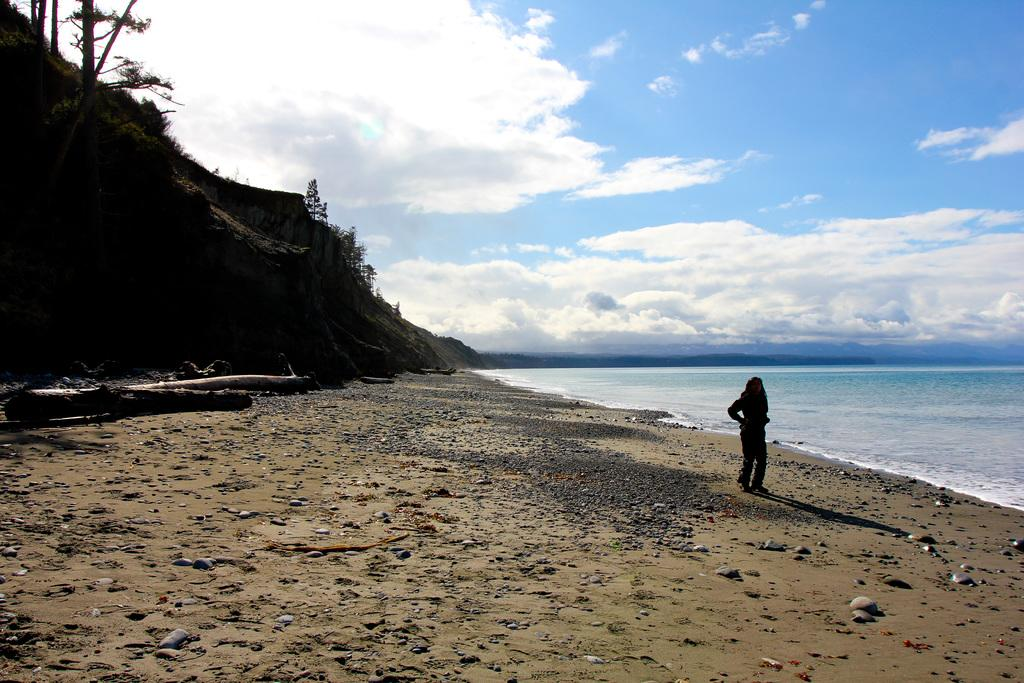What type of natural feature can be seen in the image? There is an ocean in the image. What are the women in the image doing? The women are standing in the image. What type of terrain is visible in the image? There are stones visible in the image. What type of vegetation is present in the image? There are trees in the image. What is visible in the sky in the image? The sky is visible in the image, and clouds are present. What is on the ground in the image? There are stones on the ground in the image. What is the purpose of the geese in the image? There are no geese present in the image. What type of mineral can be found in the stones in the image? The type of mineral in the stones cannot be determined from the image alone. 